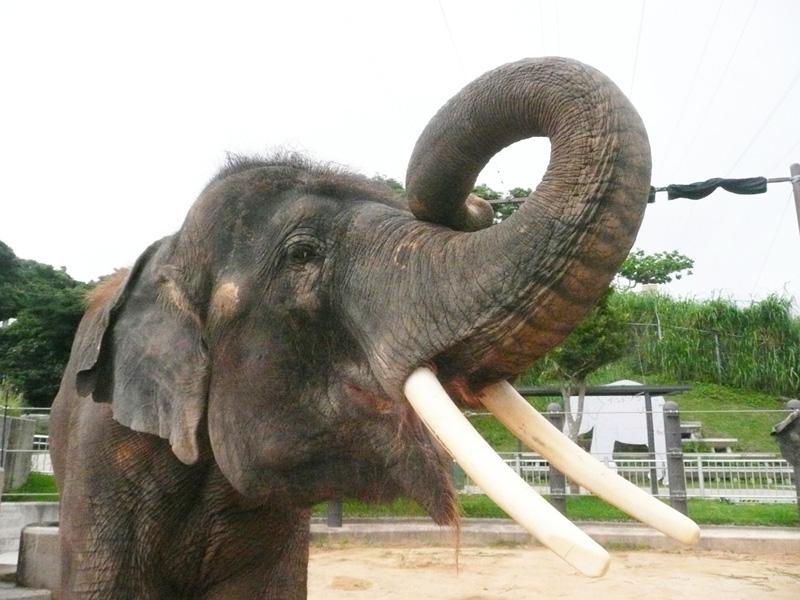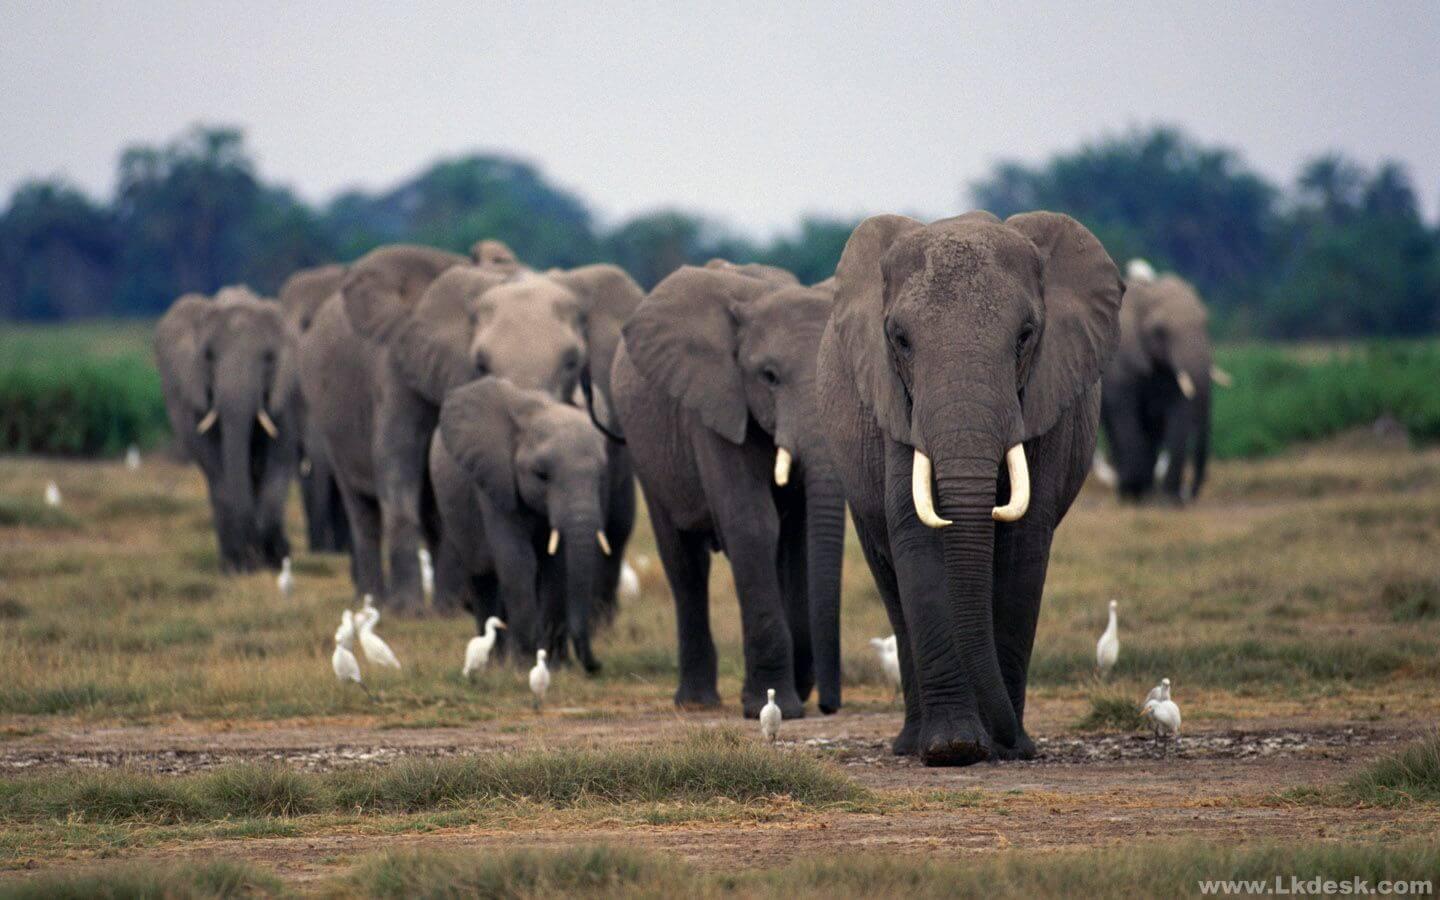The first image is the image on the left, the second image is the image on the right. For the images shown, is this caption "In the image to the right, the elephant is right before a tree." true? Answer yes or no. No. 